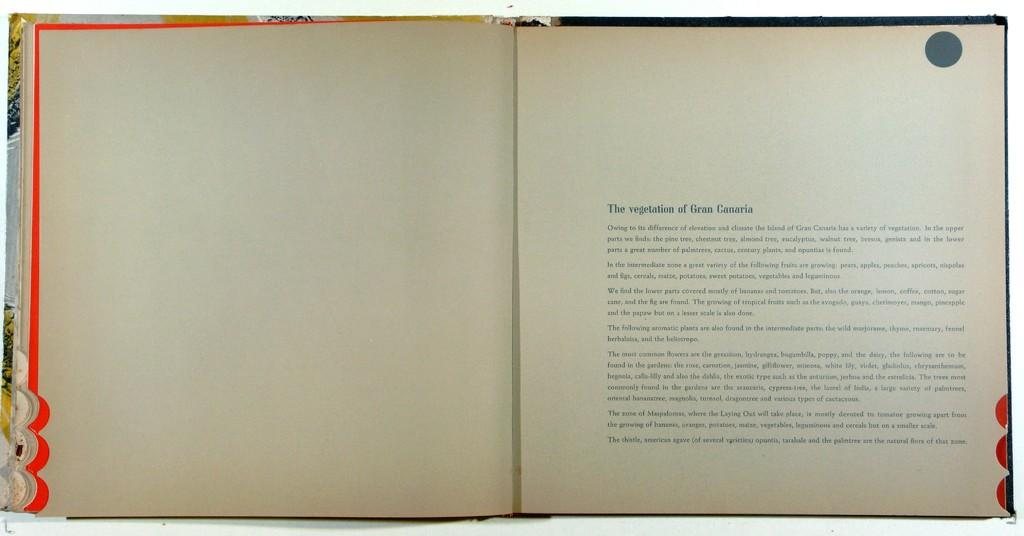<image>
Describe the image concisely. An open book with the title The vegetation of Gran Canaria and a paragraph below it. 